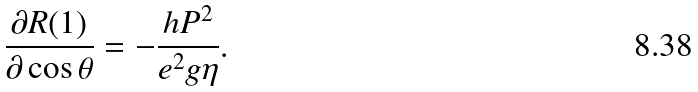<formula> <loc_0><loc_0><loc_500><loc_500>\frac { \partial R ( 1 ) } { \partial \cos \theta } = - \frac { h P ^ { 2 } } { e ^ { 2 } g \eta } .</formula> 